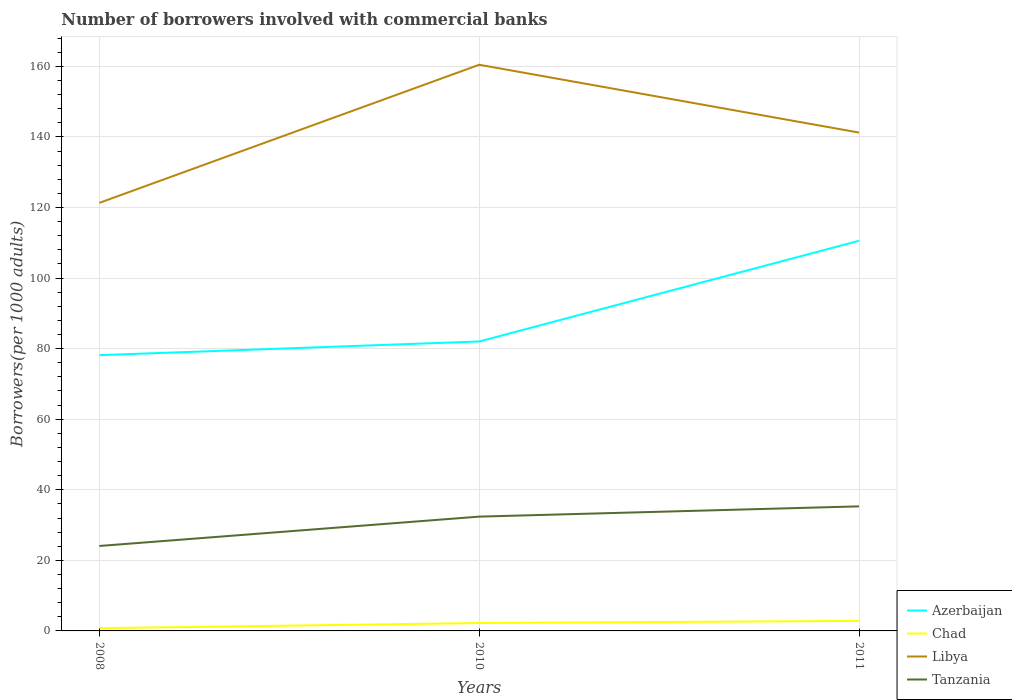Is the number of lines equal to the number of legend labels?
Make the answer very short. Yes. Across all years, what is the maximum number of borrowers involved with commercial banks in Tanzania?
Provide a short and direct response. 24.08. In which year was the number of borrowers involved with commercial banks in Azerbaijan maximum?
Offer a terse response. 2008. What is the total number of borrowers involved with commercial banks in Chad in the graph?
Ensure brevity in your answer.  -1.46. What is the difference between the highest and the second highest number of borrowers involved with commercial banks in Tanzania?
Offer a very short reply. 11.22. Is the number of borrowers involved with commercial banks in Tanzania strictly greater than the number of borrowers involved with commercial banks in Chad over the years?
Offer a terse response. No. What is the difference between two consecutive major ticks on the Y-axis?
Offer a very short reply. 20. Does the graph contain any zero values?
Provide a short and direct response. No. How many legend labels are there?
Offer a very short reply. 4. What is the title of the graph?
Your answer should be very brief. Number of borrowers involved with commercial banks. Does "Bahamas" appear as one of the legend labels in the graph?
Make the answer very short. No. What is the label or title of the X-axis?
Ensure brevity in your answer.  Years. What is the label or title of the Y-axis?
Make the answer very short. Borrowers(per 1000 adults). What is the Borrowers(per 1000 adults) of Azerbaijan in 2008?
Provide a short and direct response. 78.15. What is the Borrowers(per 1000 adults) of Chad in 2008?
Give a very brief answer. 0.77. What is the Borrowers(per 1000 adults) of Libya in 2008?
Ensure brevity in your answer.  121.31. What is the Borrowers(per 1000 adults) in Tanzania in 2008?
Make the answer very short. 24.08. What is the Borrowers(per 1000 adults) of Azerbaijan in 2010?
Provide a succinct answer. 82.02. What is the Borrowers(per 1000 adults) of Chad in 2010?
Provide a succinct answer. 2.24. What is the Borrowers(per 1000 adults) in Libya in 2010?
Offer a terse response. 160.45. What is the Borrowers(per 1000 adults) in Tanzania in 2010?
Ensure brevity in your answer.  32.39. What is the Borrowers(per 1000 adults) of Azerbaijan in 2011?
Your answer should be compact. 110.57. What is the Borrowers(per 1000 adults) of Chad in 2011?
Your answer should be compact. 2.84. What is the Borrowers(per 1000 adults) in Libya in 2011?
Keep it short and to the point. 141.22. What is the Borrowers(per 1000 adults) of Tanzania in 2011?
Give a very brief answer. 35.3. Across all years, what is the maximum Borrowers(per 1000 adults) of Azerbaijan?
Your response must be concise. 110.57. Across all years, what is the maximum Borrowers(per 1000 adults) of Chad?
Your answer should be very brief. 2.84. Across all years, what is the maximum Borrowers(per 1000 adults) in Libya?
Your response must be concise. 160.45. Across all years, what is the maximum Borrowers(per 1000 adults) of Tanzania?
Keep it short and to the point. 35.3. Across all years, what is the minimum Borrowers(per 1000 adults) of Azerbaijan?
Your answer should be very brief. 78.15. Across all years, what is the minimum Borrowers(per 1000 adults) of Chad?
Your answer should be very brief. 0.77. Across all years, what is the minimum Borrowers(per 1000 adults) in Libya?
Your response must be concise. 121.31. Across all years, what is the minimum Borrowers(per 1000 adults) in Tanzania?
Make the answer very short. 24.08. What is the total Borrowers(per 1000 adults) in Azerbaijan in the graph?
Provide a succinct answer. 270.74. What is the total Borrowers(per 1000 adults) of Chad in the graph?
Make the answer very short. 5.85. What is the total Borrowers(per 1000 adults) of Libya in the graph?
Your answer should be compact. 422.98. What is the total Borrowers(per 1000 adults) of Tanzania in the graph?
Your answer should be very brief. 91.76. What is the difference between the Borrowers(per 1000 adults) of Azerbaijan in 2008 and that in 2010?
Your response must be concise. -3.87. What is the difference between the Borrowers(per 1000 adults) of Chad in 2008 and that in 2010?
Your answer should be compact. -1.46. What is the difference between the Borrowers(per 1000 adults) in Libya in 2008 and that in 2010?
Offer a very short reply. -39.14. What is the difference between the Borrowers(per 1000 adults) of Tanzania in 2008 and that in 2010?
Your answer should be very brief. -8.32. What is the difference between the Borrowers(per 1000 adults) of Azerbaijan in 2008 and that in 2011?
Keep it short and to the point. -32.42. What is the difference between the Borrowers(per 1000 adults) in Chad in 2008 and that in 2011?
Your answer should be compact. -2.07. What is the difference between the Borrowers(per 1000 adults) in Libya in 2008 and that in 2011?
Your answer should be very brief. -19.92. What is the difference between the Borrowers(per 1000 adults) of Tanzania in 2008 and that in 2011?
Your answer should be compact. -11.22. What is the difference between the Borrowers(per 1000 adults) of Azerbaijan in 2010 and that in 2011?
Provide a succinct answer. -28.55. What is the difference between the Borrowers(per 1000 adults) of Chad in 2010 and that in 2011?
Your answer should be very brief. -0.61. What is the difference between the Borrowers(per 1000 adults) of Libya in 2010 and that in 2011?
Provide a succinct answer. 19.22. What is the difference between the Borrowers(per 1000 adults) of Tanzania in 2010 and that in 2011?
Keep it short and to the point. -2.91. What is the difference between the Borrowers(per 1000 adults) in Azerbaijan in 2008 and the Borrowers(per 1000 adults) in Chad in 2010?
Give a very brief answer. 75.91. What is the difference between the Borrowers(per 1000 adults) in Azerbaijan in 2008 and the Borrowers(per 1000 adults) in Libya in 2010?
Your answer should be compact. -82.3. What is the difference between the Borrowers(per 1000 adults) of Azerbaijan in 2008 and the Borrowers(per 1000 adults) of Tanzania in 2010?
Make the answer very short. 45.76. What is the difference between the Borrowers(per 1000 adults) of Chad in 2008 and the Borrowers(per 1000 adults) of Libya in 2010?
Ensure brevity in your answer.  -159.67. What is the difference between the Borrowers(per 1000 adults) of Chad in 2008 and the Borrowers(per 1000 adults) of Tanzania in 2010?
Provide a short and direct response. -31.62. What is the difference between the Borrowers(per 1000 adults) of Libya in 2008 and the Borrowers(per 1000 adults) of Tanzania in 2010?
Provide a short and direct response. 88.92. What is the difference between the Borrowers(per 1000 adults) of Azerbaijan in 2008 and the Borrowers(per 1000 adults) of Chad in 2011?
Keep it short and to the point. 75.31. What is the difference between the Borrowers(per 1000 adults) of Azerbaijan in 2008 and the Borrowers(per 1000 adults) of Libya in 2011?
Keep it short and to the point. -63.07. What is the difference between the Borrowers(per 1000 adults) of Azerbaijan in 2008 and the Borrowers(per 1000 adults) of Tanzania in 2011?
Ensure brevity in your answer.  42.85. What is the difference between the Borrowers(per 1000 adults) in Chad in 2008 and the Borrowers(per 1000 adults) in Libya in 2011?
Your answer should be very brief. -140.45. What is the difference between the Borrowers(per 1000 adults) of Chad in 2008 and the Borrowers(per 1000 adults) of Tanzania in 2011?
Offer a terse response. -34.53. What is the difference between the Borrowers(per 1000 adults) of Libya in 2008 and the Borrowers(per 1000 adults) of Tanzania in 2011?
Ensure brevity in your answer.  86.01. What is the difference between the Borrowers(per 1000 adults) of Azerbaijan in 2010 and the Borrowers(per 1000 adults) of Chad in 2011?
Provide a succinct answer. 79.18. What is the difference between the Borrowers(per 1000 adults) of Azerbaijan in 2010 and the Borrowers(per 1000 adults) of Libya in 2011?
Ensure brevity in your answer.  -59.2. What is the difference between the Borrowers(per 1000 adults) of Azerbaijan in 2010 and the Borrowers(per 1000 adults) of Tanzania in 2011?
Offer a terse response. 46.72. What is the difference between the Borrowers(per 1000 adults) of Chad in 2010 and the Borrowers(per 1000 adults) of Libya in 2011?
Offer a terse response. -138.99. What is the difference between the Borrowers(per 1000 adults) of Chad in 2010 and the Borrowers(per 1000 adults) of Tanzania in 2011?
Your answer should be very brief. -33.06. What is the difference between the Borrowers(per 1000 adults) of Libya in 2010 and the Borrowers(per 1000 adults) of Tanzania in 2011?
Offer a terse response. 125.15. What is the average Borrowers(per 1000 adults) of Azerbaijan per year?
Ensure brevity in your answer.  90.25. What is the average Borrowers(per 1000 adults) of Chad per year?
Keep it short and to the point. 1.95. What is the average Borrowers(per 1000 adults) of Libya per year?
Your answer should be very brief. 140.99. What is the average Borrowers(per 1000 adults) of Tanzania per year?
Provide a short and direct response. 30.59. In the year 2008, what is the difference between the Borrowers(per 1000 adults) of Azerbaijan and Borrowers(per 1000 adults) of Chad?
Offer a terse response. 77.38. In the year 2008, what is the difference between the Borrowers(per 1000 adults) of Azerbaijan and Borrowers(per 1000 adults) of Libya?
Make the answer very short. -43.16. In the year 2008, what is the difference between the Borrowers(per 1000 adults) in Azerbaijan and Borrowers(per 1000 adults) in Tanzania?
Give a very brief answer. 54.07. In the year 2008, what is the difference between the Borrowers(per 1000 adults) in Chad and Borrowers(per 1000 adults) in Libya?
Give a very brief answer. -120.53. In the year 2008, what is the difference between the Borrowers(per 1000 adults) in Chad and Borrowers(per 1000 adults) in Tanzania?
Your answer should be compact. -23.3. In the year 2008, what is the difference between the Borrowers(per 1000 adults) of Libya and Borrowers(per 1000 adults) of Tanzania?
Your response must be concise. 97.23. In the year 2010, what is the difference between the Borrowers(per 1000 adults) in Azerbaijan and Borrowers(per 1000 adults) in Chad?
Ensure brevity in your answer.  79.79. In the year 2010, what is the difference between the Borrowers(per 1000 adults) of Azerbaijan and Borrowers(per 1000 adults) of Libya?
Offer a terse response. -78.42. In the year 2010, what is the difference between the Borrowers(per 1000 adults) of Azerbaijan and Borrowers(per 1000 adults) of Tanzania?
Your response must be concise. 49.63. In the year 2010, what is the difference between the Borrowers(per 1000 adults) in Chad and Borrowers(per 1000 adults) in Libya?
Ensure brevity in your answer.  -158.21. In the year 2010, what is the difference between the Borrowers(per 1000 adults) in Chad and Borrowers(per 1000 adults) in Tanzania?
Ensure brevity in your answer.  -30.16. In the year 2010, what is the difference between the Borrowers(per 1000 adults) of Libya and Borrowers(per 1000 adults) of Tanzania?
Provide a short and direct response. 128.05. In the year 2011, what is the difference between the Borrowers(per 1000 adults) in Azerbaijan and Borrowers(per 1000 adults) in Chad?
Give a very brief answer. 107.72. In the year 2011, what is the difference between the Borrowers(per 1000 adults) of Azerbaijan and Borrowers(per 1000 adults) of Libya?
Make the answer very short. -30.66. In the year 2011, what is the difference between the Borrowers(per 1000 adults) of Azerbaijan and Borrowers(per 1000 adults) of Tanzania?
Offer a very short reply. 75.27. In the year 2011, what is the difference between the Borrowers(per 1000 adults) in Chad and Borrowers(per 1000 adults) in Libya?
Provide a succinct answer. -138.38. In the year 2011, what is the difference between the Borrowers(per 1000 adults) of Chad and Borrowers(per 1000 adults) of Tanzania?
Offer a very short reply. -32.45. In the year 2011, what is the difference between the Borrowers(per 1000 adults) in Libya and Borrowers(per 1000 adults) in Tanzania?
Your response must be concise. 105.93. What is the ratio of the Borrowers(per 1000 adults) in Azerbaijan in 2008 to that in 2010?
Offer a terse response. 0.95. What is the ratio of the Borrowers(per 1000 adults) of Chad in 2008 to that in 2010?
Your answer should be compact. 0.35. What is the ratio of the Borrowers(per 1000 adults) in Libya in 2008 to that in 2010?
Offer a terse response. 0.76. What is the ratio of the Borrowers(per 1000 adults) in Tanzania in 2008 to that in 2010?
Offer a terse response. 0.74. What is the ratio of the Borrowers(per 1000 adults) of Azerbaijan in 2008 to that in 2011?
Make the answer very short. 0.71. What is the ratio of the Borrowers(per 1000 adults) of Chad in 2008 to that in 2011?
Provide a short and direct response. 0.27. What is the ratio of the Borrowers(per 1000 adults) in Libya in 2008 to that in 2011?
Give a very brief answer. 0.86. What is the ratio of the Borrowers(per 1000 adults) of Tanzania in 2008 to that in 2011?
Your answer should be compact. 0.68. What is the ratio of the Borrowers(per 1000 adults) in Azerbaijan in 2010 to that in 2011?
Offer a terse response. 0.74. What is the ratio of the Borrowers(per 1000 adults) of Chad in 2010 to that in 2011?
Your answer should be compact. 0.79. What is the ratio of the Borrowers(per 1000 adults) of Libya in 2010 to that in 2011?
Offer a terse response. 1.14. What is the ratio of the Borrowers(per 1000 adults) in Tanzania in 2010 to that in 2011?
Your answer should be very brief. 0.92. What is the difference between the highest and the second highest Borrowers(per 1000 adults) in Azerbaijan?
Offer a very short reply. 28.55. What is the difference between the highest and the second highest Borrowers(per 1000 adults) of Chad?
Your answer should be very brief. 0.61. What is the difference between the highest and the second highest Borrowers(per 1000 adults) in Libya?
Offer a very short reply. 19.22. What is the difference between the highest and the second highest Borrowers(per 1000 adults) in Tanzania?
Provide a succinct answer. 2.91. What is the difference between the highest and the lowest Borrowers(per 1000 adults) of Azerbaijan?
Provide a short and direct response. 32.42. What is the difference between the highest and the lowest Borrowers(per 1000 adults) of Chad?
Give a very brief answer. 2.07. What is the difference between the highest and the lowest Borrowers(per 1000 adults) in Libya?
Offer a very short reply. 39.14. What is the difference between the highest and the lowest Borrowers(per 1000 adults) of Tanzania?
Your answer should be compact. 11.22. 